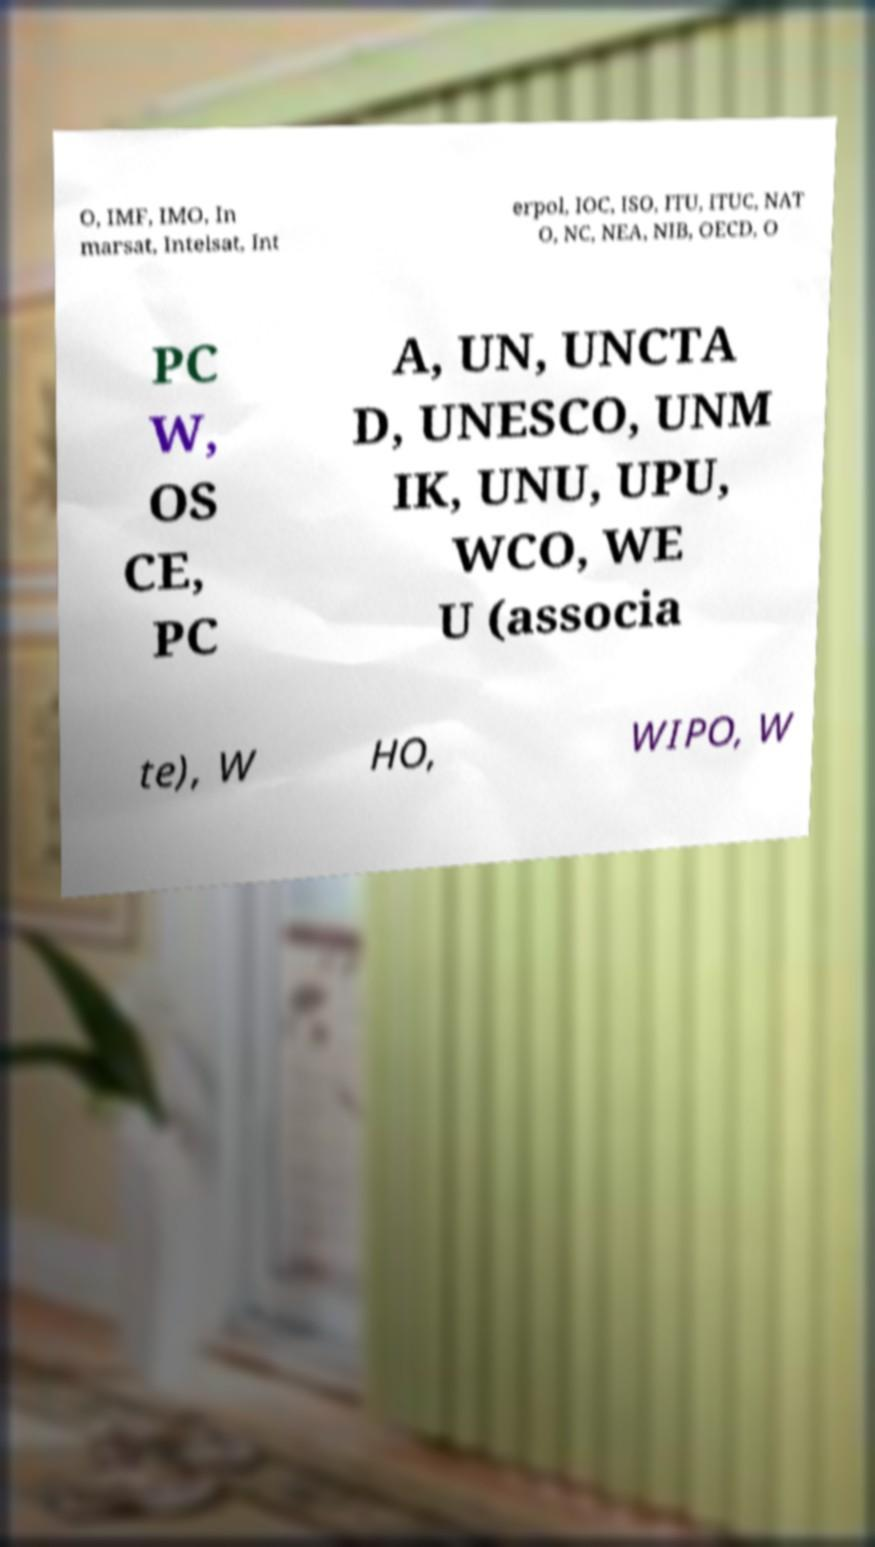What messages or text are displayed in this image? I need them in a readable, typed format. O, IMF, IMO, In marsat, Intelsat, Int erpol, IOC, ISO, ITU, ITUC, NAT O, NC, NEA, NIB, OECD, O PC W, OS CE, PC A, UN, UNCTA D, UNESCO, UNM IK, UNU, UPU, WCO, WE U (associa te), W HO, WIPO, W 